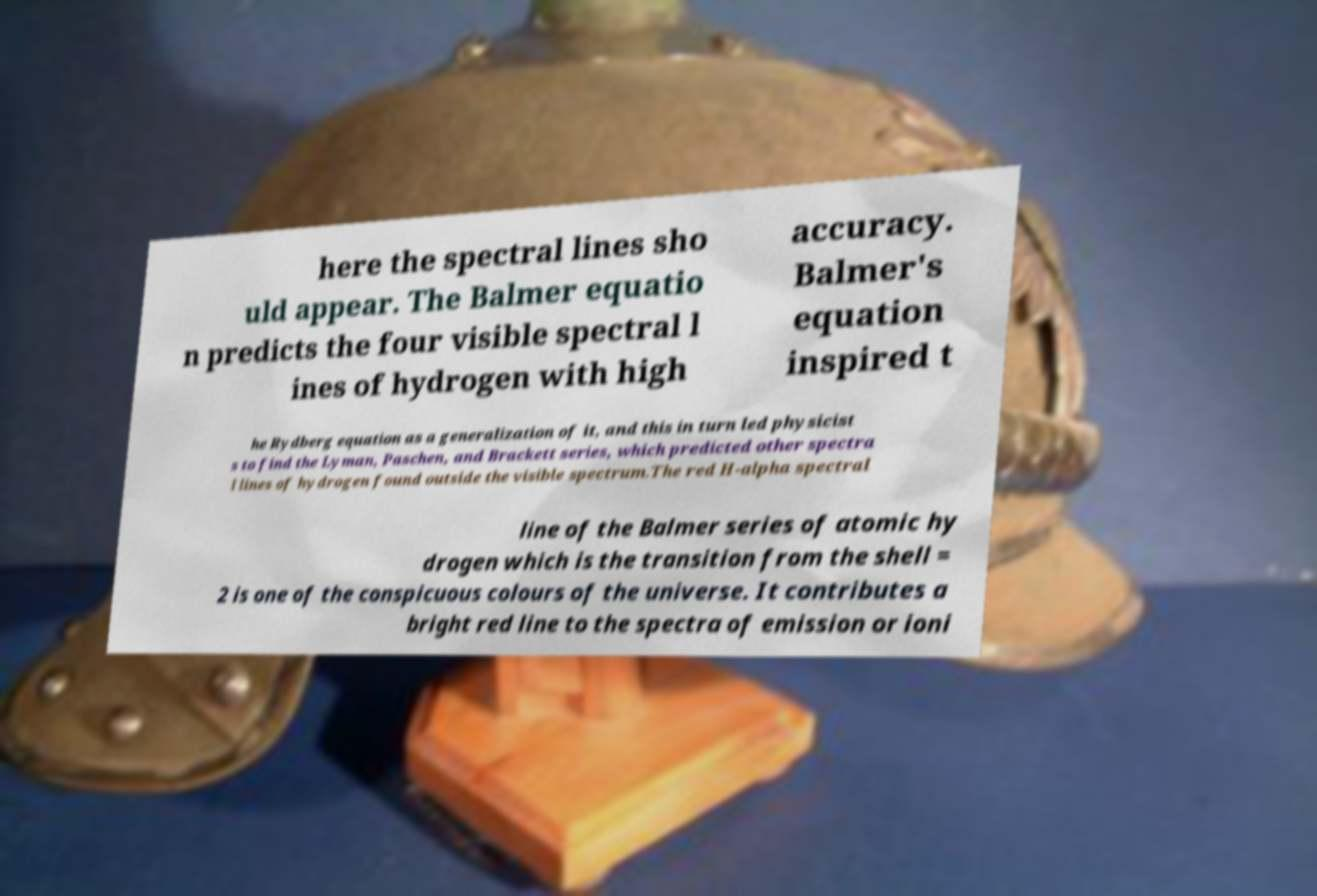Can you read and provide the text displayed in the image?This photo seems to have some interesting text. Can you extract and type it out for me? here the spectral lines sho uld appear. The Balmer equatio n predicts the four visible spectral l ines of hydrogen with high accuracy. Balmer's equation inspired t he Rydberg equation as a generalization of it, and this in turn led physicist s to find the Lyman, Paschen, and Brackett series, which predicted other spectra l lines of hydrogen found outside the visible spectrum.The red H-alpha spectral line of the Balmer series of atomic hy drogen which is the transition from the shell = 2 is one of the conspicuous colours of the universe. It contributes a bright red line to the spectra of emission or ioni 